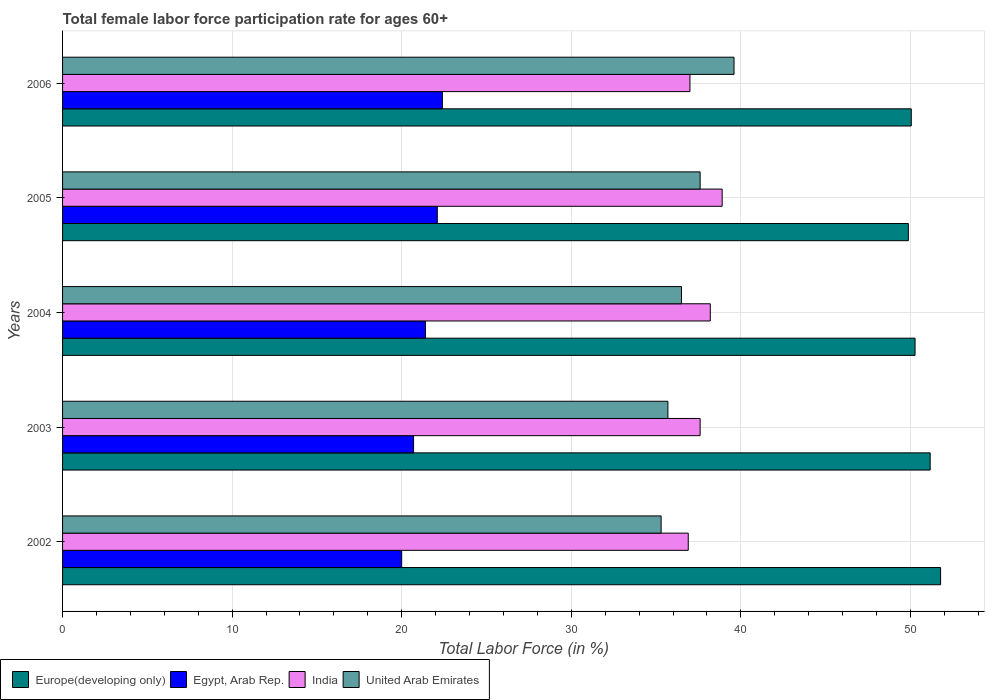How many groups of bars are there?
Your response must be concise. 5. Are the number of bars per tick equal to the number of legend labels?
Offer a terse response. Yes. How many bars are there on the 3rd tick from the bottom?
Ensure brevity in your answer.  4. What is the label of the 3rd group of bars from the top?
Your answer should be very brief. 2004. In how many cases, is the number of bars for a given year not equal to the number of legend labels?
Offer a terse response. 0. What is the female labor force participation rate in India in 2005?
Offer a terse response. 38.9. Across all years, what is the maximum female labor force participation rate in United Arab Emirates?
Make the answer very short. 39.6. Across all years, what is the minimum female labor force participation rate in Europe(developing only)?
Your answer should be very brief. 49.88. In which year was the female labor force participation rate in India maximum?
Your answer should be very brief. 2005. What is the total female labor force participation rate in Europe(developing only) in the graph?
Your answer should be compact. 253.16. What is the difference between the female labor force participation rate in United Arab Emirates in 2002 and that in 2003?
Offer a terse response. -0.4. What is the difference between the female labor force participation rate in India in 2004 and the female labor force participation rate in Egypt, Arab Rep. in 2006?
Make the answer very short. 15.8. What is the average female labor force participation rate in Europe(developing only) per year?
Offer a very short reply. 50.63. In the year 2002, what is the difference between the female labor force participation rate in Egypt, Arab Rep. and female labor force participation rate in United Arab Emirates?
Your answer should be compact. -15.3. In how many years, is the female labor force participation rate in Egypt, Arab Rep. greater than 6 %?
Give a very brief answer. 5. What is the ratio of the female labor force participation rate in Egypt, Arab Rep. in 2002 to that in 2004?
Provide a short and direct response. 0.93. Is the female labor force participation rate in Europe(developing only) in 2002 less than that in 2004?
Provide a succinct answer. No. Is the difference between the female labor force participation rate in Egypt, Arab Rep. in 2004 and 2006 greater than the difference between the female labor force participation rate in United Arab Emirates in 2004 and 2006?
Ensure brevity in your answer.  Yes. What is the difference between the highest and the second highest female labor force participation rate in Egypt, Arab Rep.?
Offer a terse response. 0.3. What is the difference between the highest and the lowest female labor force participation rate in Europe(developing only)?
Offer a terse response. 1.9. Is the sum of the female labor force participation rate in India in 2002 and 2004 greater than the maximum female labor force participation rate in United Arab Emirates across all years?
Your answer should be compact. Yes. Is it the case that in every year, the sum of the female labor force participation rate in Europe(developing only) and female labor force participation rate in United Arab Emirates is greater than the sum of female labor force participation rate in Egypt, Arab Rep. and female labor force participation rate in India?
Ensure brevity in your answer.  Yes. What does the 4th bar from the top in 2006 represents?
Keep it short and to the point. Europe(developing only). What does the 3rd bar from the bottom in 2002 represents?
Offer a terse response. India. Is it the case that in every year, the sum of the female labor force participation rate in India and female labor force participation rate in Europe(developing only) is greater than the female labor force participation rate in Egypt, Arab Rep.?
Your answer should be compact. Yes. How many bars are there?
Ensure brevity in your answer.  20. Are all the bars in the graph horizontal?
Your answer should be very brief. Yes. Does the graph contain any zero values?
Your answer should be compact. No. Does the graph contain grids?
Your answer should be compact. Yes. Where does the legend appear in the graph?
Keep it short and to the point. Bottom left. How many legend labels are there?
Offer a terse response. 4. How are the legend labels stacked?
Keep it short and to the point. Horizontal. What is the title of the graph?
Offer a very short reply. Total female labor force participation rate for ages 60+. Does "Trinidad and Tobago" appear as one of the legend labels in the graph?
Keep it short and to the point. No. What is the label or title of the Y-axis?
Your response must be concise. Years. What is the Total Labor Force (in %) of Europe(developing only) in 2002?
Keep it short and to the point. 51.78. What is the Total Labor Force (in %) of India in 2002?
Keep it short and to the point. 36.9. What is the Total Labor Force (in %) of United Arab Emirates in 2002?
Provide a short and direct response. 35.3. What is the Total Labor Force (in %) of Europe(developing only) in 2003?
Ensure brevity in your answer.  51.17. What is the Total Labor Force (in %) in Egypt, Arab Rep. in 2003?
Provide a short and direct response. 20.7. What is the Total Labor Force (in %) of India in 2003?
Provide a short and direct response. 37.6. What is the Total Labor Force (in %) of United Arab Emirates in 2003?
Give a very brief answer. 35.7. What is the Total Labor Force (in %) in Europe(developing only) in 2004?
Provide a succinct answer. 50.28. What is the Total Labor Force (in %) of Egypt, Arab Rep. in 2004?
Ensure brevity in your answer.  21.4. What is the Total Labor Force (in %) in India in 2004?
Ensure brevity in your answer.  38.2. What is the Total Labor Force (in %) in United Arab Emirates in 2004?
Make the answer very short. 36.5. What is the Total Labor Force (in %) of Europe(developing only) in 2005?
Ensure brevity in your answer.  49.88. What is the Total Labor Force (in %) in Egypt, Arab Rep. in 2005?
Your answer should be compact. 22.1. What is the Total Labor Force (in %) in India in 2005?
Offer a very short reply. 38.9. What is the Total Labor Force (in %) of United Arab Emirates in 2005?
Your answer should be very brief. 37.6. What is the Total Labor Force (in %) in Europe(developing only) in 2006?
Ensure brevity in your answer.  50.05. What is the Total Labor Force (in %) of Egypt, Arab Rep. in 2006?
Ensure brevity in your answer.  22.4. What is the Total Labor Force (in %) in United Arab Emirates in 2006?
Offer a terse response. 39.6. Across all years, what is the maximum Total Labor Force (in %) of Europe(developing only)?
Offer a terse response. 51.78. Across all years, what is the maximum Total Labor Force (in %) in Egypt, Arab Rep.?
Your answer should be compact. 22.4. Across all years, what is the maximum Total Labor Force (in %) in India?
Keep it short and to the point. 38.9. Across all years, what is the maximum Total Labor Force (in %) of United Arab Emirates?
Your answer should be very brief. 39.6. Across all years, what is the minimum Total Labor Force (in %) of Europe(developing only)?
Your answer should be compact. 49.88. Across all years, what is the minimum Total Labor Force (in %) in Egypt, Arab Rep.?
Provide a succinct answer. 20. Across all years, what is the minimum Total Labor Force (in %) in India?
Provide a short and direct response. 36.9. Across all years, what is the minimum Total Labor Force (in %) in United Arab Emirates?
Provide a succinct answer. 35.3. What is the total Total Labor Force (in %) in Europe(developing only) in the graph?
Give a very brief answer. 253.16. What is the total Total Labor Force (in %) in Egypt, Arab Rep. in the graph?
Your answer should be compact. 106.6. What is the total Total Labor Force (in %) in India in the graph?
Your answer should be compact. 188.6. What is the total Total Labor Force (in %) of United Arab Emirates in the graph?
Provide a succinct answer. 184.7. What is the difference between the Total Labor Force (in %) in Europe(developing only) in 2002 and that in 2003?
Provide a succinct answer. 0.61. What is the difference between the Total Labor Force (in %) of Egypt, Arab Rep. in 2002 and that in 2003?
Offer a terse response. -0.7. What is the difference between the Total Labor Force (in %) in India in 2002 and that in 2003?
Your response must be concise. -0.7. What is the difference between the Total Labor Force (in %) in Europe(developing only) in 2002 and that in 2004?
Provide a short and direct response. 1.51. What is the difference between the Total Labor Force (in %) in Egypt, Arab Rep. in 2002 and that in 2004?
Provide a short and direct response. -1.4. What is the difference between the Total Labor Force (in %) of United Arab Emirates in 2002 and that in 2004?
Offer a very short reply. -1.2. What is the difference between the Total Labor Force (in %) in Europe(developing only) in 2002 and that in 2005?
Provide a succinct answer. 1.9. What is the difference between the Total Labor Force (in %) in India in 2002 and that in 2005?
Provide a short and direct response. -2. What is the difference between the Total Labor Force (in %) in United Arab Emirates in 2002 and that in 2005?
Keep it short and to the point. -2.3. What is the difference between the Total Labor Force (in %) of Europe(developing only) in 2002 and that in 2006?
Your response must be concise. 1.73. What is the difference between the Total Labor Force (in %) of India in 2002 and that in 2006?
Your answer should be compact. -0.1. What is the difference between the Total Labor Force (in %) of Europe(developing only) in 2003 and that in 2004?
Offer a terse response. 0.89. What is the difference between the Total Labor Force (in %) of Egypt, Arab Rep. in 2003 and that in 2004?
Your response must be concise. -0.7. What is the difference between the Total Labor Force (in %) in United Arab Emirates in 2003 and that in 2004?
Offer a terse response. -0.8. What is the difference between the Total Labor Force (in %) in Europe(developing only) in 2003 and that in 2005?
Give a very brief answer. 1.29. What is the difference between the Total Labor Force (in %) in Egypt, Arab Rep. in 2003 and that in 2005?
Keep it short and to the point. -1.4. What is the difference between the Total Labor Force (in %) in India in 2003 and that in 2005?
Your response must be concise. -1.3. What is the difference between the Total Labor Force (in %) of Europe(developing only) in 2003 and that in 2006?
Your answer should be compact. 1.12. What is the difference between the Total Labor Force (in %) of Egypt, Arab Rep. in 2003 and that in 2006?
Keep it short and to the point. -1.7. What is the difference between the Total Labor Force (in %) of India in 2003 and that in 2006?
Your response must be concise. 0.6. What is the difference between the Total Labor Force (in %) of Europe(developing only) in 2004 and that in 2005?
Offer a very short reply. 0.4. What is the difference between the Total Labor Force (in %) in United Arab Emirates in 2004 and that in 2005?
Offer a very short reply. -1.1. What is the difference between the Total Labor Force (in %) of Europe(developing only) in 2004 and that in 2006?
Provide a succinct answer. 0.22. What is the difference between the Total Labor Force (in %) of United Arab Emirates in 2004 and that in 2006?
Provide a succinct answer. -3.1. What is the difference between the Total Labor Force (in %) of Europe(developing only) in 2005 and that in 2006?
Offer a very short reply. -0.17. What is the difference between the Total Labor Force (in %) of India in 2005 and that in 2006?
Keep it short and to the point. 1.9. What is the difference between the Total Labor Force (in %) in United Arab Emirates in 2005 and that in 2006?
Your answer should be compact. -2. What is the difference between the Total Labor Force (in %) of Europe(developing only) in 2002 and the Total Labor Force (in %) of Egypt, Arab Rep. in 2003?
Your answer should be very brief. 31.08. What is the difference between the Total Labor Force (in %) in Europe(developing only) in 2002 and the Total Labor Force (in %) in India in 2003?
Your answer should be compact. 14.18. What is the difference between the Total Labor Force (in %) in Europe(developing only) in 2002 and the Total Labor Force (in %) in United Arab Emirates in 2003?
Give a very brief answer. 16.08. What is the difference between the Total Labor Force (in %) of Egypt, Arab Rep. in 2002 and the Total Labor Force (in %) of India in 2003?
Give a very brief answer. -17.6. What is the difference between the Total Labor Force (in %) in Egypt, Arab Rep. in 2002 and the Total Labor Force (in %) in United Arab Emirates in 2003?
Give a very brief answer. -15.7. What is the difference between the Total Labor Force (in %) of India in 2002 and the Total Labor Force (in %) of United Arab Emirates in 2003?
Ensure brevity in your answer.  1.2. What is the difference between the Total Labor Force (in %) in Europe(developing only) in 2002 and the Total Labor Force (in %) in Egypt, Arab Rep. in 2004?
Your response must be concise. 30.38. What is the difference between the Total Labor Force (in %) in Europe(developing only) in 2002 and the Total Labor Force (in %) in India in 2004?
Your response must be concise. 13.58. What is the difference between the Total Labor Force (in %) in Europe(developing only) in 2002 and the Total Labor Force (in %) in United Arab Emirates in 2004?
Ensure brevity in your answer.  15.28. What is the difference between the Total Labor Force (in %) in Egypt, Arab Rep. in 2002 and the Total Labor Force (in %) in India in 2004?
Ensure brevity in your answer.  -18.2. What is the difference between the Total Labor Force (in %) in Egypt, Arab Rep. in 2002 and the Total Labor Force (in %) in United Arab Emirates in 2004?
Offer a terse response. -16.5. What is the difference between the Total Labor Force (in %) in Europe(developing only) in 2002 and the Total Labor Force (in %) in Egypt, Arab Rep. in 2005?
Make the answer very short. 29.68. What is the difference between the Total Labor Force (in %) of Europe(developing only) in 2002 and the Total Labor Force (in %) of India in 2005?
Make the answer very short. 12.88. What is the difference between the Total Labor Force (in %) of Europe(developing only) in 2002 and the Total Labor Force (in %) of United Arab Emirates in 2005?
Offer a very short reply. 14.18. What is the difference between the Total Labor Force (in %) in Egypt, Arab Rep. in 2002 and the Total Labor Force (in %) in India in 2005?
Keep it short and to the point. -18.9. What is the difference between the Total Labor Force (in %) in Egypt, Arab Rep. in 2002 and the Total Labor Force (in %) in United Arab Emirates in 2005?
Ensure brevity in your answer.  -17.6. What is the difference between the Total Labor Force (in %) in Europe(developing only) in 2002 and the Total Labor Force (in %) in Egypt, Arab Rep. in 2006?
Give a very brief answer. 29.38. What is the difference between the Total Labor Force (in %) in Europe(developing only) in 2002 and the Total Labor Force (in %) in India in 2006?
Keep it short and to the point. 14.78. What is the difference between the Total Labor Force (in %) in Europe(developing only) in 2002 and the Total Labor Force (in %) in United Arab Emirates in 2006?
Your answer should be compact. 12.18. What is the difference between the Total Labor Force (in %) of Egypt, Arab Rep. in 2002 and the Total Labor Force (in %) of United Arab Emirates in 2006?
Offer a terse response. -19.6. What is the difference between the Total Labor Force (in %) of India in 2002 and the Total Labor Force (in %) of United Arab Emirates in 2006?
Provide a short and direct response. -2.7. What is the difference between the Total Labor Force (in %) in Europe(developing only) in 2003 and the Total Labor Force (in %) in Egypt, Arab Rep. in 2004?
Your answer should be very brief. 29.77. What is the difference between the Total Labor Force (in %) of Europe(developing only) in 2003 and the Total Labor Force (in %) of India in 2004?
Ensure brevity in your answer.  12.97. What is the difference between the Total Labor Force (in %) in Europe(developing only) in 2003 and the Total Labor Force (in %) in United Arab Emirates in 2004?
Keep it short and to the point. 14.67. What is the difference between the Total Labor Force (in %) in Egypt, Arab Rep. in 2003 and the Total Labor Force (in %) in India in 2004?
Provide a succinct answer. -17.5. What is the difference between the Total Labor Force (in %) in Egypt, Arab Rep. in 2003 and the Total Labor Force (in %) in United Arab Emirates in 2004?
Make the answer very short. -15.8. What is the difference between the Total Labor Force (in %) of Europe(developing only) in 2003 and the Total Labor Force (in %) of Egypt, Arab Rep. in 2005?
Give a very brief answer. 29.07. What is the difference between the Total Labor Force (in %) in Europe(developing only) in 2003 and the Total Labor Force (in %) in India in 2005?
Ensure brevity in your answer.  12.27. What is the difference between the Total Labor Force (in %) of Europe(developing only) in 2003 and the Total Labor Force (in %) of United Arab Emirates in 2005?
Offer a very short reply. 13.57. What is the difference between the Total Labor Force (in %) of Egypt, Arab Rep. in 2003 and the Total Labor Force (in %) of India in 2005?
Keep it short and to the point. -18.2. What is the difference between the Total Labor Force (in %) of Egypt, Arab Rep. in 2003 and the Total Labor Force (in %) of United Arab Emirates in 2005?
Offer a terse response. -16.9. What is the difference between the Total Labor Force (in %) of India in 2003 and the Total Labor Force (in %) of United Arab Emirates in 2005?
Ensure brevity in your answer.  0. What is the difference between the Total Labor Force (in %) of Europe(developing only) in 2003 and the Total Labor Force (in %) of Egypt, Arab Rep. in 2006?
Provide a succinct answer. 28.77. What is the difference between the Total Labor Force (in %) in Europe(developing only) in 2003 and the Total Labor Force (in %) in India in 2006?
Keep it short and to the point. 14.17. What is the difference between the Total Labor Force (in %) in Europe(developing only) in 2003 and the Total Labor Force (in %) in United Arab Emirates in 2006?
Your answer should be compact. 11.57. What is the difference between the Total Labor Force (in %) in Egypt, Arab Rep. in 2003 and the Total Labor Force (in %) in India in 2006?
Provide a succinct answer. -16.3. What is the difference between the Total Labor Force (in %) of Egypt, Arab Rep. in 2003 and the Total Labor Force (in %) of United Arab Emirates in 2006?
Make the answer very short. -18.9. What is the difference between the Total Labor Force (in %) in India in 2003 and the Total Labor Force (in %) in United Arab Emirates in 2006?
Your response must be concise. -2. What is the difference between the Total Labor Force (in %) of Europe(developing only) in 2004 and the Total Labor Force (in %) of Egypt, Arab Rep. in 2005?
Your answer should be compact. 28.18. What is the difference between the Total Labor Force (in %) of Europe(developing only) in 2004 and the Total Labor Force (in %) of India in 2005?
Ensure brevity in your answer.  11.38. What is the difference between the Total Labor Force (in %) of Europe(developing only) in 2004 and the Total Labor Force (in %) of United Arab Emirates in 2005?
Provide a short and direct response. 12.68. What is the difference between the Total Labor Force (in %) of Egypt, Arab Rep. in 2004 and the Total Labor Force (in %) of India in 2005?
Your answer should be very brief. -17.5. What is the difference between the Total Labor Force (in %) of Egypt, Arab Rep. in 2004 and the Total Labor Force (in %) of United Arab Emirates in 2005?
Your response must be concise. -16.2. What is the difference between the Total Labor Force (in %) in Europe(developing only) in 2004 and the Total Labor Force (in %) in Egypt, Arab Rep. in 2006?
Make the answer very short. 27.88. What is the difference between the Total Labor Force (in %) of Europe(developing only) in 2004 and the Total Labor Force (in %) of India in 2006?
Your answer should be very brief. 13.28. What is the difference between the Total Labor Force (in %) of Europe(developing only) in 2004 and the Total Labor Force (in %) of United Arab Emirates in 2006?
Your answer should be very brief. 10.68. What is the difference between the Total Labor Force (in %) in Egypt, Arab Rep. in 2004 and the Total Labor Force (in %) in India in 2006?
Your answer should be compact. -15.6. What is the difference between the Total Labor Force (in %) in Egypt, Arab Rep. in 2004 and the Total Labor Force (in %) in United Arab Emirates in 2006?
Provide a short and direct response. -18.2. What is the difference between the Total Labor Force (in %) of India in 2004 and the Total Labor Force (in %) of United Arab Emirates in 2006?
Your response must be concise. -1.4. What is the difference between the Total Labor Force (in %) of Europe(developing only) in 2005 and the Total Labor Force (in %) of Egypt, Arab Rep. in 2006?
Give a very brief answer. 27.48. What is the difference between the Total Labor Force (in %) in Europe(developing only) in 2005 and the Total Labor Force (in %) in India in 2006?
Provide a succinct answer. 12.88. What is the difference between the Total Labor Force (in %) of Europe(developing only) in 2005 and the Total Labor Force (in %) of United Arab Emirates in 2006?
Give a very brief answer. 10.28. What is the difference between the Total Labor Force (in %) of Egypt, Arab Rep. in 2005 and the Total Labor Force (in %) of India in 2006?
Your answer should be compact. -14.9. What is the difference between the Total Labor Force (in %) in Egypt, Arab Rep. in 2005 and the Total Labor Force (in %) in United Arab Emirates in 2006?
Ensure brevity in your answer.  -17.5. What is the difference between the Total Labor Force (in %) in India in 2005 and the Total Labor Force (in %) in United Arab Emirates in 2006?
Keep it short and to the point. -0.7. What is the average Total Labor Force (in %) in Europe(developing only) per year?
Your response must be concise. 50.63. What is the average Total Labor Force (in %) of Egypt, Arab Rep. per year?
Provide a short and direct response. 21.32. What is the average Total Labor Force (in %) of India per year?
Make the answer very short. 37.72. What is the average Total Labor Force (in %) in United Arab Emirates per year?
Provide a succinct answer. 36.94. In the year 2002, what is the difference between the Total Labor Force (in %) in Europe(developing only) and Total Labor Force (in %) in Egypt, Arab Rep.?
Make the answer very short. 31.78. In the year 2002, what is the difference between the Total Labor Force (in %) of Europe(developing only) and Total Labor Force (in %) of India?
Your answer should be very brief. 14.88. In the year 2002, what is the difference between the Total Labor Force (in %) in Europe(developing only) and Total Labor Force (in %) in United Arab Emirates?
Ensure brevity in your answer.  16.48. In the year 2002, what is the difference between the Total Labor Force (in %) in Egypt, Arab Rep. and Total Labor Force (in %) in India?
Provide a short and direct response. -16.9. In the year 2002, what is the difference between the Total Labor Force (in %) of Egypt, Arab Rep. and Total Labor Force (in %) of United Arab Emirates?
Offer a very short reply. -15.3. In the year 2002, what is the difference between the Total Labor Force (in %) in India and Total Labor Force (in %) in United Arab Emirates?
Offer a terse response. 1.6. In the year 2003, what is the difference between the Total Labor Force (in %) of Europe(developing only) and Total Labor Force (in %) of Egypt, Arab Rep.?
Provide a short and direct response. 30.47. In the year 2003, what is the difference between the Total Labor Force (in %) of Europe(developing only) and Total Labor Force (in %) of India?
Provide a succinct answer. 13.57. In the year 2003, what is the difference between the Total Labor Force (in %) of Europe(developing only) and Total Labor Force (in %) of United Arab Emirates?
Give a very brief answer. 15.47. In the year 2003, what is the difference between the Total Labor Force (in %) of Egypt, Arab Rep. and Total Labor Force (in %) of India?
Provide a short and direct response. -16.9. In the year 2003, what is the difference between the Total Labor Force (in %) in India and Total Labor Force (in %) in United Arab Emirates?
Your answer should be compact. 1.9. In the year 2004, what is the difference between the Total Labor Force (in %) in Europe(developing only) and Total Labor Force (in %) in Egypt, Arab Rep.?
Keep it short and to the point. 28.88. In the year 2004, what is the difference between the Total Labor Force (in %) in Europe(developing only) and Total Labor Force (in %) in India?
Make the answer very short. 12.08. In the year 2004, what is the difference between the Total Labor Force (in %) in Europe(developing only) and Total Labor Force (in %) in United Arab Emirates?
Your answer should be compact. 13.78. In the year 2004, what is the difference between the Total Labor Force (in %) in Egypt, Arab Rep. and Total Labor Force (in %) in India?
Make the answer very short. -16.8. In the year 2004, what is the difference between the Total Labor Force (in %) of Egypt, Arab Rep. and Total Labor Force (in %) of United Arab Emirates?
Offer a very short reply. -15.1. In the year 2004, what is the difference between the Total Labor Force (in %) in India and Total Labor Force (in %) in United Arab Emirates?
Your answer should be very brief. 1.7. In the year 2005, what is the difference between the Total Labor Force (in %) in Europe(developing only) and Total Labor Force (in %) in Egypt, Arab Rep.?
Provide a short and direct response. 27.78. In the year 2005, what is the difference between the Total Labor Force (in %) in Europe(developing only) and Total Labor Force (in %) in India?
Make the answer very short. 10.98. In the year 2005, what is the difference between the Total Labor Force (in %) of Europe(developing only) and Total Labor Force (in %) of United Arab Emirates?
Make the answer very short. 12.28. In the year 2005, what is the difference between the Total Labor Force (in %) of Egypt, Arab Rep. and Total Labor Force (in %) of India?
Give a very brief answer. -16.8. In the year 2005, what is the difference between the Total Labor Force (in %) of Egypt, Arab Rep. and Total Labor Force (in %) of United Arab Emirates?
Your response must be concise. -15.5. In the year 2005, what is the difference between the Total Labor Force (in %) of India and Total Labor Force (in %) of United Arab Emirates?
Provide a succinct answer. 1.3. In the year 2006, what is the difference between the Total Labor Force (in %) of Europe(developing only) and Total Labor Force (in %) of Egypt, Arab Rep.?
Your answer should be very brief. 27.65. In the year 2006, what is the difference between the Total Labor Force (in %) in Europe(developing only) and Total Labor Force (in %) in India?
Offer a terse response. 13.05. In the year 2006, what is the difference between the Total Labor Force (in %) of Europe(developing only) and Total Labor Force (in %) of United Arab Emirates?
Give a very brief answer. 10.45. In the year 2006, what is the difference between the Total Labor Force (in %) in Egypt, Arab Rep. and Total Labor Force (in %) in India?
Give a very brief answer. -14.6. In the year 2006, what is the difference between the Total Labor Force (in %) in Egypt, Arab Rep. and Total Labor Force (in %) in United Arab Emirates?
Offer a terse response. -17.2. What is the ratio of the Total Labor Force (in %) in Egypt, Arab Rep. in 2002 to that in 2003?
Your answer should be very brief. 0.97. What is the ratio of the Total Labor Force (in %) of India in 2002 to that in 2003?
Keep it short and to the point. 0.98. What is the ratio of the Total Labor Force (in %) in Europe(developing only) in 2002 to that in 2004?
Ensure brevity in your answer.  1.03. What is the ratio of the Total Labor Force (in %) in Egypt, Arab Rep. in 2002 to that in 2004?
Your response must be concise. 0.93. What is the ratio of the Total Labor Force (in %) of United Arab Emirates in 2002 to that in 2004?
Ensure brevity in your answer.  0.97. What is the ratio of the Total Labor Force (in %) of Europe(developing only) in 2002 to that in 2005?
Provide a succinct answer. 1.04. What is the ratio of the Total Labor Force (in %) in Egypt, Arab Rep. in 2002 to that in 2005?
Make the answer very short. 0.91. What is the ratio of the Total Labor Force (in %) of India in 2002 to that in 2005?
Provide a short and direct response. 0.95. What is the ratio of the Total Labor Force (in %) of United Arab Emirates in 2002 to that in 2005?
Offer a very short reply. 0.94. What is the ratio of the Total Labor Force (in %) in Europe(developing only) in 2002 to that in 2006?
Your response must be concise. 1.03. What is the ratio of the Total Labor Force (in %) of Egypt, Arab Rep. in 2002 to that in 2006?
Your response must be concise. 0.89. What is the ratio of the Total Labor Force (in %) of United Arab Emirates in 2002 to that in 2006?
Ensure brevity in your answer.  0.89. What is the ratio of the Total Labor Force (in %) in Europe(developing only) in 2003 to that in 2004?
Offer a very short reply. 1.02. What is the ratio of the Total Labor Force (in %) in Egypt, Arab Rep. in 2003 to that in 2004?
Ensure brevity in your answer.  0.97. What is the ratio of the Total Labor Force (in %) of India in 2003 to that in 2004?
Ensure brevity in your answer.  0.98. What is the ratio of the Total Labor Force (in %) in United Arab Emirates in 2003 to that in 2004?
Give a very brief answer. 0.98. What is the ratio of the Total Labor Force (in %) of Europe(developing only) in 2003 to that in 2005?
Your answer should be very brief. 1.03. What is the ratio of the Total Labor Force (in %) of Egypt, Arab Rep. in 2003 to that in 2005?
Your answer should be compact. 0.94. What is the ratio of the Total Labor Force (in %) in India in 2003 to that in 2005?
Provide a succinct answer. 0.97. What is the ratio of the Total Labor Force (in %) of United Arab Emirates in 2003 to that in 2005?
Your response must be concise. 0.95. What is the ratio of the Total Labor Force (in %) in Europe(developing only) in 2003 to that in 2006?
Offer a terse response. 1.02. What is the ratio of the Total Labor Force (in %) of Egypt, Arab Rep. in 2003 to that in 2006?
Give a very brief answer. 0.92. What is the ratio of the Total Labor Force (in %) in India in 2003 to that in 2006?
Your response must be concise. 1.02. What is the ratio of the Total Labor Force (in %) in United Arab Emirates in 2003 to that in 2006?
Ensure brevity in your answer.  0.9. What is the ratio of the Total Labor Force (in %) of Europe(developing only) in 2004 to that in 2005?
Offer a terse response. 1.01. What is the ratio of the Total Labor Force (in %) of Egypt, Arab Rep. in 2004 to that in 2005?
Your answer should be compact. 0.97. What is the ratio of the Total Labor Force (in %) in India in 2004 to that in 2005?
Your response must be concise. 0.98. What is the ratio of the Total Labor Force (in %) in United Arab Emirates in 2004 to that in 2005?
Your answer should be very brief. 0.97. What is the ratio of the Total Labor Force (in %) of Egypt, Arab Rep. in 2004 to that in 2006?
Give a very brief answer. 0.96. What is the ratio of the Total Labor Force (in %) in India in 2004 to that in 2006?
Your response must be concise. 1.03. What is the ratio of the Total Labor Force (in %) in United Arab Emirates in 2004 to that in 2006?
Make the answer very short. 0.92. What is the ratio of the Total Labor Force (in %) in Europe(developing only) in 2005 to that in 2006?
Offer a terse response. 1. What is the ratio of the Total Labor Force (in %) of Egypt, Arab Rep. in 2005 to that in 2006?
Your response must be concise. 0.99. What is the ratio of the Total Labor Force (in %) of India in 2005 to that in 2006?
Provide a short and direct response. 1.05. What is the ratio of the Total Labor Force (in %) of United Arab Emirates in 2005 to that in 2006?
Provide a short and direct response. 0.95. What is the difference between the highest and the second highest Total Labor Force (in %) in Europe(developing only)?
Ensure brevity in your answer.  0.61. What is the difference between the highest and the second highest Total Labor Force (in %) of Egypt, Arab Rep.?
Keep it short and to the point. 0.3. What is the difference between the highest and the second highest Total Labor Force (in %) of India?
Offer a very short reply. 0.7. What is the difference between the highest and the second highest Total Labor Force (in %) of United Arab Emirates?
Keep it short and to the point. 2. What is the difference between the highest and the lowest Total Labor Force (in %) of Europe(developing only)?
Ensure brevity in your answer.  1.9. 